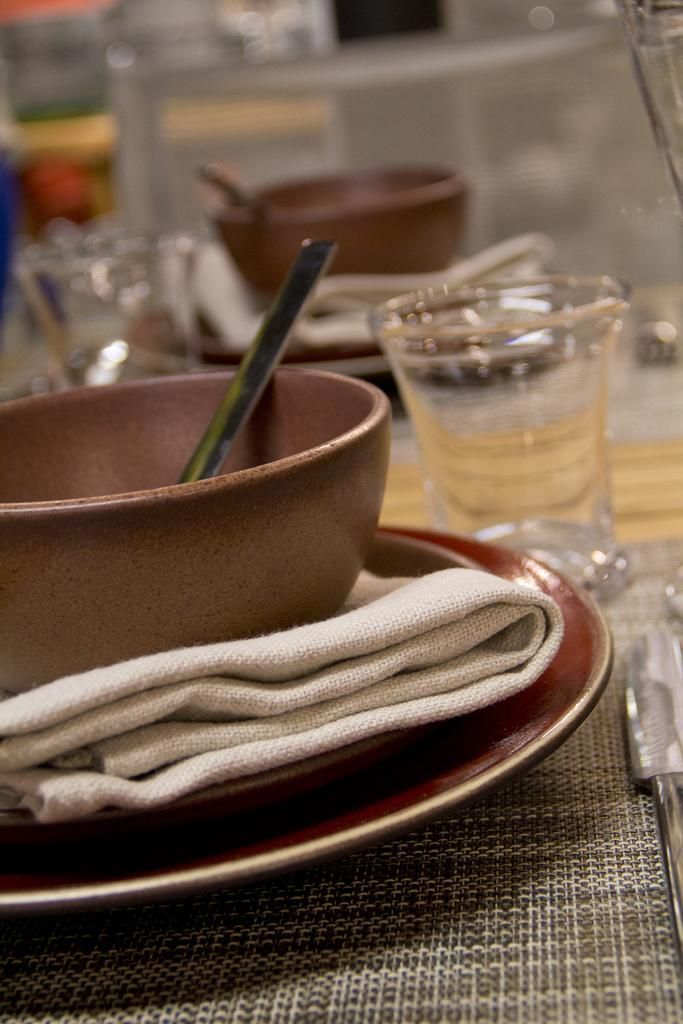What is located in the foreground of the picture? There is a table in the foreground of the picture. What items can be seen on the table? Glasses, plates, bowls, spoons, and tissues are on the table. Are there any other objects on the table? Yes, there are other objects on the table. What can be observed about the background of the image? The background of the image is blurred. Can you see any fairies flying around the table in the image? No, there are no fairies present in the image. What type of feather can be seen on the table in the image? There is no feather visible on the table in the image. 